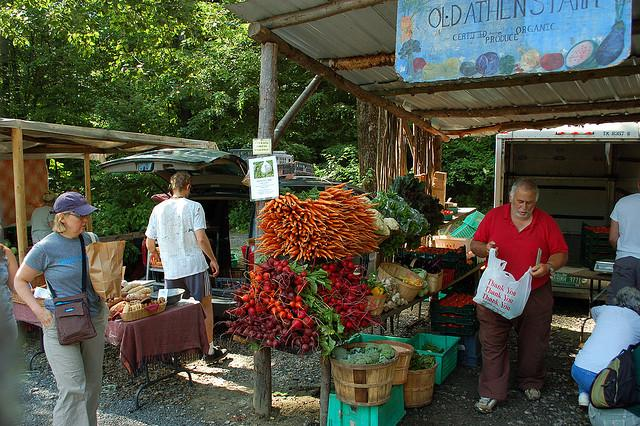Beta carotene rich vegetable in the image is? carrot 